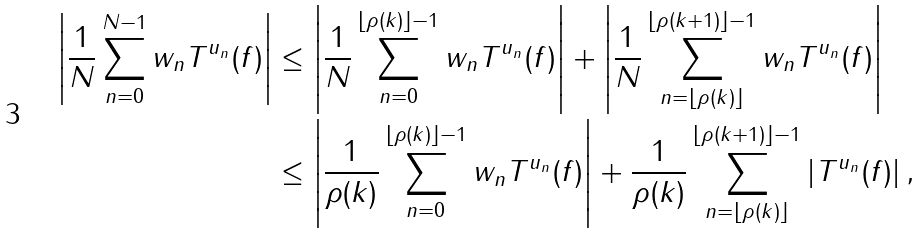<formula> <loc_0><loc_0><loc_500><loc_500>\left | \frac { 1 } { N } \sum _ { n = 0 } ^ { N - 1 } w _ { n } T ^ { u _ { n } } ( f ) \right | & \leq \left | \frac { 1 } { N } \sum _ { n = 0 } ^ { \lfloor \rho ( k ) \rfloor - 1 } w _ { n } T ^ { u _ { n } } ( f ) \right | + \left | \frac { 1 } { N } \sum _ { n = \lfloor \rho ( k ) \rfloor } ^ { \lfloor \rho ( k + 1 ) \rfloor - 1 } w _ { n } T ^ { u _ { n } } ( f ) \right | \\ & \leq \left | \frac { 1 } { \rho ( k ) } \sum _ { n = 0 } ^ { \lfloor \rho ( k ) \rfloor - 1 } w _ { n } T ^ { u _ { n } } ( f ) \right | + \frac { 1 } { \rho ( k ) } \sum _ { n = \lfloor \rho ( k ) \rfloor } ^ { \lfloor \rho ( k + 1 ) \rfloor - 1 } \left | T ^ { u _ { n } } ( f ) \right | ,</formula> 